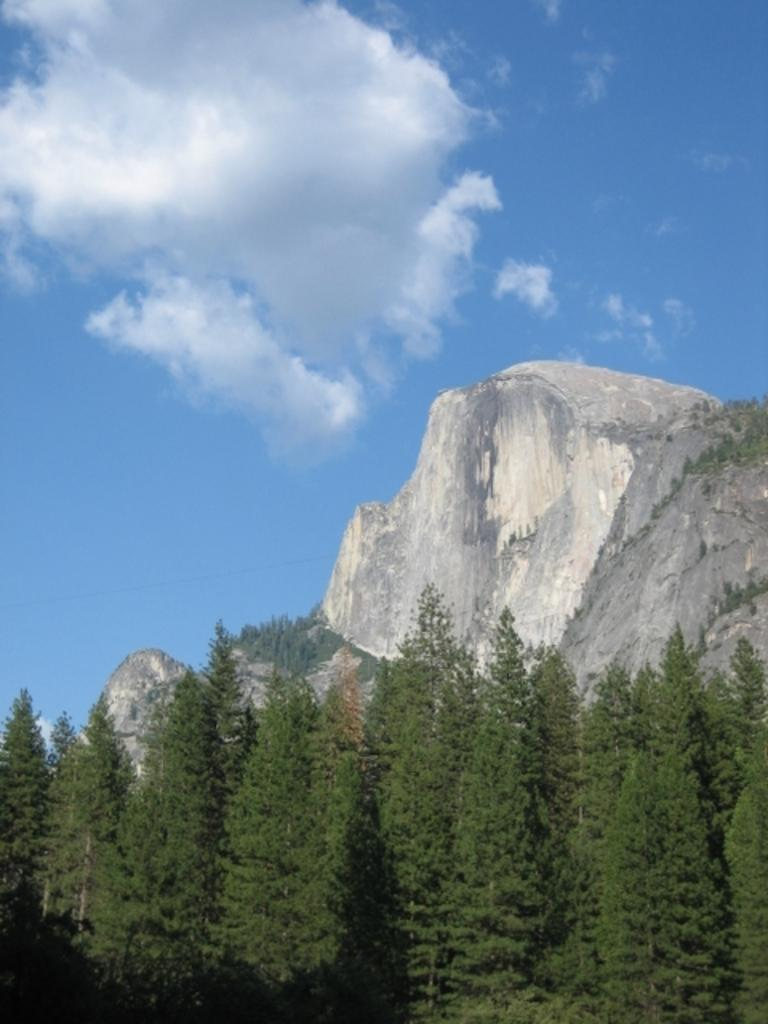What type of natural environment is depicted in the image? The image features many trees and a mountain, indicating a forest or mountainous landscape. Can you describe the sky in the image? Clouds are visible at the top of the image, suggesting that the sky is partly cloudy. How many porters can be seen carrying supplies up the mountain in the image? There are no porters or supplies visible in the image; it features trees, a mountain, and clouds. What type of sea creature is swimming among the trees in the image? There are no sea creatures, such as jellyfish, present in the image; it features trees, a mountain, and clouds. 